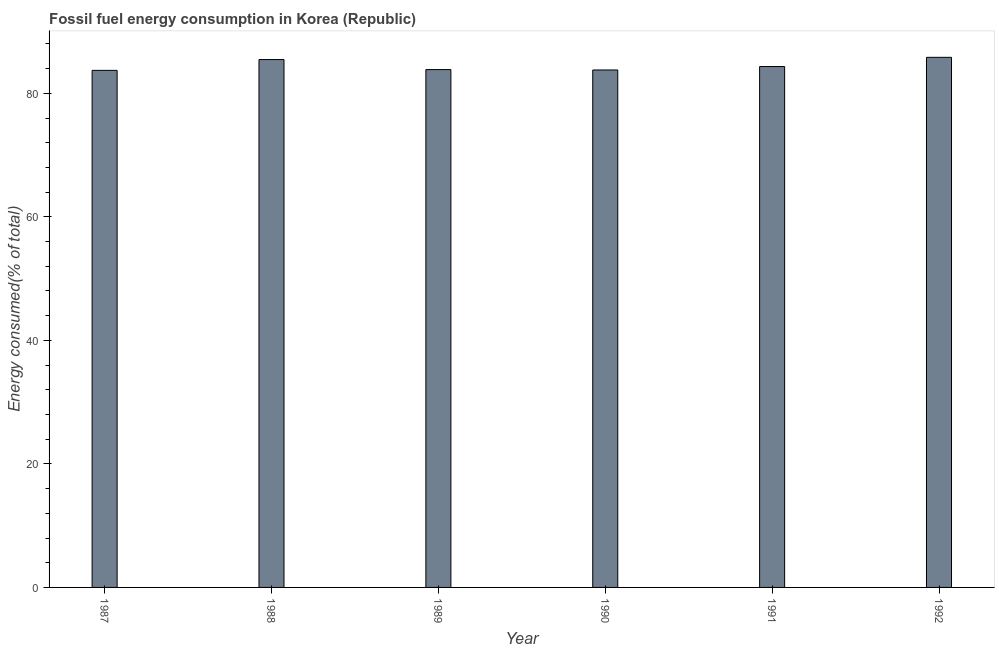What is the title of the graph?
Make the answer very short. Fossil fuel energy consumption in Korea (Republic). What is the label or title of the Y-axis?
Offer a very short reply. Energy consumed(% of total). What is the fossil fuel energy consumption in 1991?
Keep it short and to the point. 84.34. Across all years, what is the maximum fossil fuel energy consumption?
Provide a short and direct response. 85.83. Across all years, what is the minimum fossil fuel energy consumption?
Your response must be concise. 83.72. In which year was the fossil fuel energy consumption maximum?
Provide a short and direct response. 1992. In which year was the fossil fuel energy consumption minimum?
Provide a succinct answer. 1987. What is the sum of the fossil fuel energy consumption?
Offer a very short reply. 506.97. What is the difference between the fossil fuel energy consumption in 1989 and 1991?
Provide a succinct answer. -0.49. What is the average fossil fuel energy consumption per year?
Provide a short and direct response. 84.5. What is the median fossil fuel energy consumption?
Keep it short and to the point. 84.09. Do a majority of the years between 1990 and 1988 (inclusive) have fossil fuel energy consumption greater than 68 %?
Your response must be concise. Yes. What is the ratio of the fossil fuel energy consumption in 1988 to that in 1990?
Your answer should be very brief. 1.02. Is the fossil fuel energy consumption in 1990 less than that in 1992?
Make the answer very short. Yes. Is the difference between the fossil fuel energy consumption in 1989 and 1991 greater than the difference between any two years?
Your answer should be compact. No. What is the difference between the highest and the second highest fossil fuel energy consumption?
Your answer should be very brief. 0.36. What is the difference between the highest and the lowest fossil fuel energy consumption?
Keep it short and to the point. 2.11. How many bars are there?
Provide a succinct answer. 6. Are all the bars in the graph horizontal?
Your answer should be compact. No. How many years are there in the graph?
Your response must be concise. 6. What is the difference between two consecutive major ticks on the Y-axis?
Your answer should be compact. 20. Are the values on the major ticks of Y-axis written in scientific E-notation?
Give a very brief answer. No. What is the Energy consumed(% of total) of 1987?
Ensure brevity in your answer.  83.72. What is the Energy consumed(% of total) in 1988?
Provide a short and direct response. 85.47. What is the Energy consumed(% of total) in 1989?
Offer a terse response. 83.84. What is the Energy consumed(% of total) in 1990?
Offer a terse response. 83.78. What is the Energy consumed(% of total) of 1991?
Provide a succinct answer. 84.34. What is the Energy consumed(% of total) of 1992?
Provide a succinct answer. 85.83. What is the difference between the Energy consumed(% of total) in 1987 and 1988?
Your answer should be compact. -1.75. What is the difference between the Energy consumed(% of total) in 1987 and 1989?
Your answer should be very brief. -0.12. What is the difference between the Energy consumed(% of total) in 1987 and 1990?
Your response must be concise. -0.06. What is the difference between the Energy consumed(% of total) in 1987 and 1991?
Provide a succinct answer. -0.62. What is the difference between the Energy consumed(% of total) in 1987 and 1992?
Offer a terse response. -2.11. What is the difference between the Energy consumed(% of total) in 1988 and 1989?
Ensure brevity in your answer.  1.62. What is the difference between the Energy consumed(% of total) in 1988 and 1990?
Provide a short and direct response. 1.69. What is the difference between the Energy consumed(% of total) in 1988 and 1991?
Your answer should be compact. 1.13. What is the difference between the Energy consumed(% of total) in 1988 and 1992?
Your answer should be compact. -0.36. What is the difference between the Energy consumed(% of total) in 1989 and 1990?
Your answer should be compact. 0.06. What is the difference between the Energy consumed(% of total) in 1989 and 1991?
Offer a terse response. -0.49. What is the difference between the Energy consumed(% of total) in 1989 and 1992?
Provide a short and direct response. -1.99. What is the difference between the Energy consumed(% of total) in 1990 and 1991?
Offer a terse response. -0.56. What is the difference between the Energy consumed(% of total) in 1990 and 1992?
Make the answer very short. -2.05. What is the difference between the Energy consumed(% of total) in 1991 and 1992?
Your answer should be very brief. -1.49. What is the ratio of the Energy consumed(% of total) in 1987 to that in 1989?
Your answer should be compact. 1. What is the ratio of the Energy consumed(% of total) in 1987 to that in 1990?
Your answer should be compact. 1. What is the ratio of the Energy consumed(% of total) in 1989 to that in 1991?
Offer a terse response. 0.99. What is the ratio of the Energy consumed(% of total) in 1990 to that in 1991?
Your response must be concise. 0.99. What is the ratio of the Energy consumed(% of total) in 1990 to that in 1992?
Ensure brevity in your answer.  0.98. What is the ratio of the Energy consumed(% of total) in 1991 to that in 1992?
Provide a succinct answer. 0.98. 